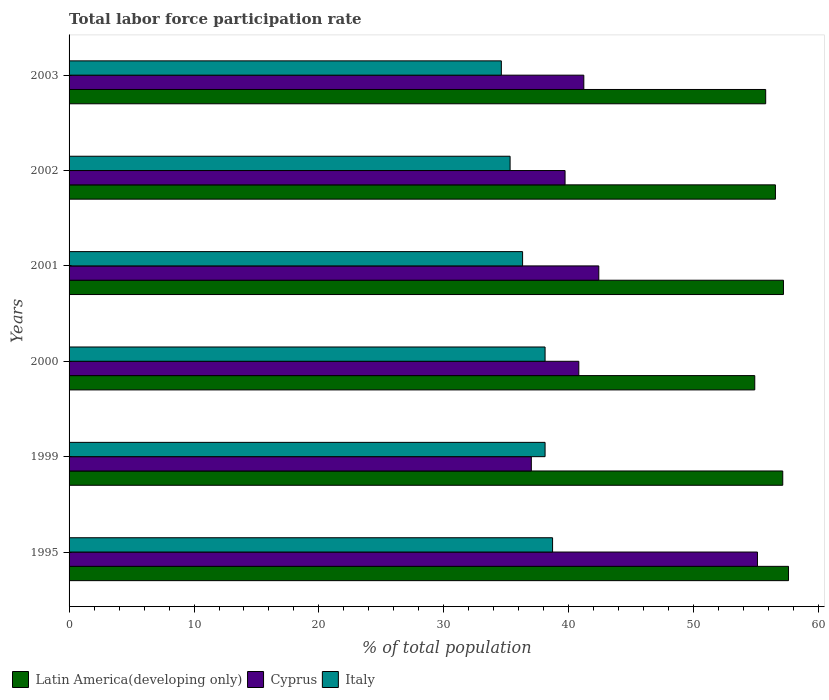How many different coloured bars are there?
Give a very brief answer. 3. Are the number of bars per tick equal to the number of legend labels?
Your answer should be compact. Yes. Are the number of bars on each tick of the Y-axis equal?
Your answer should be compact. Yes. How many bars are there on the 6th tick from the top?
Offer a very short reply. 3. How many bars are there on the 4th tick from the bottom?
Keep it short and to the point. 3. What is the label of the 3rd group of bars from the top?
Your answer should be compact. 2001. What is the total labor force participation rate in Italy in 2000?
Make the answer very short. 38.1. Across all years, what is the maximum total labor force participation rate in Cyprus?
Your answer should be compact. 55.1. Across all years, what is the minimum total labor force participation rate in Latin America(developing only)?
Give a very brief answer. 54.88. In which year was the total labor force participation rate in Cyprus maximum?
Offer a terse response. 1995. In which year was the total labor force participation rate in Latin America(developing only) minimum?
Ensure brevity in your answer.  2000. What is the total total labor force participation rate in Italy in the graph?
Make the answer very short. 221.1. What is the difference between the total labor force participation rate in Italy in 1999 and that in 2000?
Offer a very short reply. 0. What is the difference between the total labor force participation rate in Latin America(developing only) in 2000 and the total labor force participation rate in Italy in 1999?
Your answer should be compact. 16.78. What is the average total labor force participation rate in Italy per year?
Offer a terse response. 36.85. In the year 1999, what is the difference between the total labor force participation rate in Latin America(developing only) and total labor force participation rate in Cyprus?
Ensure brevity in your answer.  20.12. In how many years, is the total labor force participation rate in Cyprus greater than 54 %?
Your answer should be compact. 1. What is the ratio of the total labor force participation rate in Latin America(developing only) in 1995 to that in 2003?
Give a very brief answer. 1.03. Is the total labor force participation rate in Cyprus in 1995 less than that in 2003?
Keep it short and to the point. No. What is the difference between the highest and the second highest total labor force participation rate in Cyprus?
Provide a short and direct response. 12.7. What is the difference between the highest and the lowest total labor force participation rate in Cyprus?
Give a very brief answer. 18.1. What does the 2nd bar from the top in 1999 represents?
Make the answer very short. Cyprus. Is it the case that in every year, the sum of the total labor force participation rate in Cyprus and total labor force participation rate in Italy is greater than the total labor force participation rate in Latin America(developing only)?
Your response must be concise. Yes. How many bars are there?
Ensure brevity in your answer.  18. How many years are there in the graph?
Make the answer very short. 6. What is the difference between two consecutive major ticks on the X-axis?
Provide a short and direct response. 10. Are the values on the major ticks of X-axis written in scientific E-notation?
Give a very brief answer. No. What is the title of the graph?
Offer a very short reply. Total labor force participation rate. Does "Pacific island small states" appear as one of the legend labels in the graph?
Provide a short and direct response. No. What is the label or title of the X-axis?
Give a very brief answer. % of total population. What is the label or title of the Y-axis?
Your answer should be compact. Years. What is the % of total population in Latin America(developing only) in 1995?
Offer a terse response. 57.59. What is the % of total population of Cyprus in 1995?
Your response must be concise. 55.1. What is the % of total population of Italy in 1995?
Offer a terse response. 38.7. What is the % of total population of Latin America(developing only) in 1999?
Provide a succinct answer. 57.12. What is the % of total population in Cyprus in 1999?
Ensure brevity in your answer.  37. What is the % of total population in Italy in 1999?
Make the answer very short. 38.1. What is the % of total population in Latin America(developing only) in 2000?
Your answer should be compact. 54.88. What is the % of total population in Cyprus in 2000?
Offer a terse response. 40.8. What is the % of total population of Italy in 2000?
Give a very brief answer. 38.1. What is the % of total population of Latin America(developing only) in 2001?
Your answer should be compact. 57.18. What is the % of total population in Cyprus in 2001?
Provide a succinct answer. 42.4. What is the % of total population of Italy in 2001?
Keep it short and to the point. 36.3. What is the % of total population in Latin America(developing only) in 2002?
Give a very brief answer. 56.54. What is the % of total population of Cyprus in 2002?
Your answer should be compact. 39.7. What is the % of total population of Italy in 2002?
Give a very brief answer. 35.3. What is the % of total population of Latin America(developing only) in 2003?
Offer a terse response. 55.76. What is the % of total population in Cyprus in 2003?
Your answer should be very brief. 41.2. What is the % of total population of Italy in 2003?
Offer a very short reply. 34.6. Across all years, what is the maximum % of total population in Latin America(developing only)?
Your answer should be very brief. 57.59. Across all years, what is the maximum % of total population in Cyprus?
Give a very brief answer. 55.1. Across all years, what is the maximum % of total population of Italy?
Ensure brevity in your answer.  38.7. Across all years, what is the minimum % of total population in Latin America(developing only)?
Make the answer very short. 54.88. Across all years, what is the minimum % of total population of Italy?
Keep it short and to the point. 34.6. What is the total % of total population in Latin America(developing only) in the graph?
Provide a short and direct response. 339.07. What is the total % of total population of Cyprus in the graph?
Provide a short and direct response. 256.2. What is the total % of total population in Italy in the graph?
Provide a short and direct response. 221.1. What is the difference between the % of total population of Latin America(developing only) in 1995 and that in 1999?
Ensure brevity in your answer.  0.46. What is the difference between the % of total population of Cyprus in 1995 and that in 1999?
Provide a succinct answer. 18.1. What is the difference between the % of total population of Italy in 1995 and that in 1999?
Provide a succinct answer. 0.6. What is the difference between the % of total population in Latin America(developing only) in 1995 and that in 2000?
Keep it short and to the point. 2.7. What is the difference between the % of total population of Latin America(developing only) in 1995 and that in 2001?
Give a very brief answer. 0.41. What is the difference between the % of total population of Latin America(developing only) in 1995 and that in 2002?
Give a very brief answer. 1.05. What is the difference between the % of total population of Cyprus in 1995 and that in 2002?
Keep it short and to the point. 15.4. What is the difference between the % of total population of Italy in 1995 and that in 2002?
Ensure brevity in your answer.  3.4. What is the difference between the % of total population in Latin America(developing only) in 1995 and that in 2003?
Your response must be concise. 1.83. What is the difference between the % of total population of Cyprus in 1995 and that in 2003?
Ensure brevity in your answer.  13.9. What is the difference between the % of total population in Italy in 1995 and that in 2003?
Offer a very short reply. 4.1. What is the difference between the % of total population of Latin America(developing only) in 1999 and that in 2000?
Ensure brevity in your answer.  2.24. What is the difference between the % of total population in Cyprus in 1999 and that in 2000?
Your response must be concise. -3.8. What is the difference between the % of total population of Italy in 1999 and that in 2000?
Your response must be concise. 0. What is the difference between the % of total population in Latin America(developing only) in 1999 and that in 2001?
Ensure brevity in your answer.  -0.06. What is the difference between the % of total population in Cyprus in 1999 and that in 2001?
Your answer should be very brief. -5.4. What is the difference between the % of total population of Italy in 1999 and that in 2001?
Provide a succinct answer. 1.8. What is the difference between the % of total population of Latin America(developing only) in 1999 and that in 2002?
Provide a succinct answer. 0.59. What is the difference between the % of total population in Italy in 1999 and that in 2002?
Make the answer very short. 2.8. What is the difference between the % of total population of Latin America(developing only) in 1999 and that in 2003?
Provide a short and direct response. 1.37. What is the difference between the % of total population in Cyprus in 1999 and that in 2003?
Ensure brevity in your answer.  -4.2. What is the difference between the % of total population in Latin America(developing only) in 2000 and that in 2001?
Your response must be concise. -2.3. What is the difference between the % of total population in Italy in 2000 and that in 2001?
Keep it short and to the point. 1.8. What is the difference between the % of total population in Latin America(developing only) in 2000 and that in 2002?
Offer a very short reply. -1.65. What is the difference between the % of total population of Cyprus in 2000 and that in 2002?
Ensure brevity in your answer.  1.1. What is the difference between the % of total population in Italy in 2000 and that in 2002?
Provide a short and direct response. 2.8. What is the difference between the % of total population in Latin America(developing only) in 2000 and that in 2003?
Your response must be concise. -0.87. What is the difference between the % of total population in Italy in 2000 and that in 2003?
Offer a terse response. 3.5. What is the difference between the % of total population in Latin America(developing only) in 2001 and that in 2002?
Your answer should be compact. 0.64. What is the difference between the % of total population in Latin America(developing only) in 2001 and that in 2003?
Your answer should be very brief. 1.42. What is the difference between the % of total population of Cyprus in 2001 and that in 2003?
Offer a terse response. 1.2. What is the difference between the % of total population of Italy in 2001 and that in 2003?
Your answer should be very brief. 1.7. What is the difference between the % of total population of Latin America(developing only) in 2002 and that in 2003?
Make the answer very short. 0.78. What is the difference between the % of total population in Italy in 2002 and that in 2003?
Make the answer very short. 0.7. What is the difference between the % of total population of Latin America(developing only) in 1995 and the % of total population of Cyprus in 1999?
Ensure brevity in your answer.  20.59. What is the difference between the % of total population in Latin America(developing only) in 1995 and the % of total population in Italy in 1999?
Your response must be concise. 19.49. What is the difference between the % of total population of Latin America(developing only) in 1995 and the % of total population of Cyprus in 2000?
Offer a terse response. 16.79. What is the difference between the % of total population of Latin America(developing only) in 1995 and the % of total population of Italy in 2000?
Give a very brief answer. 19.49. What is the difference between the % of total population in Cyprus in 1995 and the % of total population in Italy in 2000?
Your answer should be compact. 17. What is the difference between the % of total population of Latin America(developing only) in 1995 and the % of total population of Cyprus in 2001?
Give a very brief answer. 15.19. What is the difference between the % of total population in Latin America(developing only) in 1995 and the % of total population in Italy in 2001?
Keep it short and to the point. 21.29. What is the difference between the % of total population in Latin America(developing only) in 1995 and the % of total population in Cyprus in 2002?
Ensure brevity in your answer.  17.89. What is the difference between the % of total population in Latin America(developing only) in 1995 and the % of total population in Italy in 2002?
Your answer should be very brief. 22.29. What is the difference between the % of total population of Cyprus in 1995 and the % of total population of Italy in 2002?
Make the answer very short. 19.8. What is the difference between the % of total population in Latin America(developing only) in 1995 and the % of total population in Cyprus in 2003?
Offer a very short reply. 16.39. What is the difference between the % of total population in Latin America(developing only) in 1995 and the % of total population in Italy in 2003?
Offer a terse response. 22.99. What is the difference between the % of total population of Latin America(developing only) in 1999 and the % of total population of Cyprus in 2000?
Your answer should be very brief. 16.32. What is the difference between the % of total population in Latin America(developing only) in 1999 and the % of total population in Italy in 2000?
Keep it short and to the point. 19.02. What is the difference between the % of total population of Cyprus in 1999 and the % of total population of Italy in 2000?
Keep it short and to the point. -1.1. What is the difference between the % of total population in Latin America(developing only) in 1999 and the % of total population in Cyprus in 2001?
Offer a terse response. 14.72. What is the difference between the % of total population in Latin America(developing only) in 1999 and the % of total population in Italy in 2001?
Your answer should be compact. 20.82. What is the difference between the % of total population of Cyprus in 1999 and the % of total population of Italy in 2001?
Your answer should be very brief. 0.7. What is the difference between the % of total population in Latin America(developing only) in 1999 and the % of total population in Cyprus in 2002?
Your response must be concise. 17.42. What is the difference between the % of total population in Latin America(developing only) in 1999 and the % of total population in Italy in 2002?
Make the answer very short. 21.82. What is the difference between the % of total population of Latin America(developing only) in 1999 and the % of total population of Cyprus in 2003?
Keep it short and to the point. 15.92. What is the difference between the % of total population of Latin America(developing only) in 1999 and the % of total population of Italy in 2003?
Ensure brevity in your answer.  22.52. What is the difference between the % of total population of Latin America(developing only) in 2000 and the % of total population of Cyprus in 2001?
Keep it short and to the point. 12.48. What is the difference between the % of total population of Latin America(developing only) in 2000 and the % of total population of Italy in 2001?
Make the answer very short. 18.58. What is the difference between the % of total population in Cyprus in 2000 and the % of total population in Italy in 2001?
Provide a short and direct response. 4.5. What is the difference between the % of total population of Latin America(developing only) in 2000 and the % of total population of Cyprus in 2002?
Your response must be concise. 15.18. What is the difference between the % of total population in Latin America(developing only) in 2000 and the % of total population in Italy in 2002?
Give a very brief answer. 19.58. What is the difference between the % of total population in Latin America(developing only) in 2000 and the % of total population in Cyprus in 2003?
Keep it short and to the point. 13.68. What is the difference between the % of total population in Latin America(developing only) in 2000 and the % of total population in Italy in 2003?
Keep it short and to the point. 20.28. What is the difference between the % of total population in Latin America(developing only) in 2001 and the % of total population in Cyprus in 2002?
Make the answer very short. 17.48. What is the difference between the % of total population of Latin America(developing only) in 2001 and the % of total population of Italy in 2002?
Keep it short and to the point. 21.88. What is the difference between the % of total population in Cyprus in 2001 and the % of total population in Italy in 2002?
Offer a very short reply. 7.1. What is the difference between the % of total population in Latin America(developing only) in 2001 and the % of total population in Cyprus in 2003?
Keep it short and to the point. 15.98. What is the difference between the % of total population in Latin America(developing only) in 2001 and the % of total population in Italy in 2003?
Your answer should be compact. 22.58. What is the difference between the % of total population in Latin America(developing only) in 2002 and the % of total population in Cyprus in 2003?
Your answer should be very brief. 15.34. What is the difference between the % of total population in Latin America(developing only) in 2002 and the % of total population in Italy in 2003?
Offer a terse response. 21.94. What is the average % of total population in Latin America(developing only) per year?
Provide a succinct answer. 56.51. What is the average % of total population in Cyprus per year?
Your answer should be very brief. 42.7. What is the average % of total population in Italy per year?
Keep it short and to the point. 36.85. In the year 1995, what is the difference between the % of total population in Latin America(developing only) and % of total population in Cyprus?
Your answer should be very brief. 2.49. In the year 1995, what is the difference between the % of total population of Latin America(developing only) and % of total population of Italy?
Ensure brevity in your answer.  18.89. In the year 1999, what is the difference between the % of total population in Latin America(developing only) and % of total population in Cyprus?
Provide a short and direct response. 20.12. In the year 1999, what is the difference between the % of total population of Latin America(developing only) and % of total population of Italy?
Your answer should be very brief. 19.02. In the year 1999, what is the difference between the % of total population in Cyprus and % of total population in Italy?
Keep it short and to the point. -1.1. In the year 2000, what is the difference between the % of total population of Latin America(developing only) and % of total population of Cyprus?
Make the answer very short. 14.08. In the year 2000, what is the difference between the % of total population in Latin America(developing only) and % of total population in Italy?
Give a very brief answer. 16.78. In the year 2001, what is the difference between the % of total population of Latin America(developing only) and % of total population of Cyprus?
Give a very brief answer. 14.78. In the year 2001, what is the difference between the % of total population in Latin America(developing only) and % of total population in Italy?
Give a very brief answer. 20.88. In the year 2002, what is the difference between the % of total population in Latin America(developing only) and % of total population in Cyprus?
Your answer should be compact. 16.84. In the year 2002, what is the difference between the % of total population in Latin America(developing only) and % of total population in Italy?
Offer a very short reply. 21.24. In the year 2002, what is the difference between the % of total population in Cyprus and % of total population in Italy?
Provide a succinct answer. 4.4. In the year 2003, what is the difference between the % of total population in Latin America(developing only) and % of total population in Cyprus?
Provide a succinct answer. 14.56. In the year 2003, what is the difference between the % of total population in Latin America(developing only) and % of total population in Italy?
Your answer should be compact. 21.16. In the year 2003, what is the difference between the % of total population of Cyprus and % of total population of Italy?
Ensure brevity in your answer.  6.6. What is the ratio of the % of total population of Cyprus in 1995 to that in 1999?
Offer a very short reply. 1.49. What is the ratio of the % of total population of Italy in 1995 to that in 1999?
Keep it short and to the point. 1.02. What is the ratio of the % of total population of Latin America(developing only) in 1995 to that in 2000?
Keep it short and to the point. 1.05. What is the ratio of the % of total population in Cyprus in 1995 to that in 2000?
Keep it short and to the point. 1.35. What is the ratio of the % of total population in Italy in 1995 to that in 2000?
Keep it short and to the point. 1.02. What is the ratio of the % of total population of Latin America(developing only) in 1995 to that in 2001?
Provide a short and direct response. 1.01. What is the ratio of the % of total population in Cyprus in 1995 to that in 2001?
Provide a short and direct response. 1.3. What is the ratio of the % of total population of Italy in 1995 to that in 2001?
Ensure brevity in your answer.  1.07. What is the ratio of the % of total population in Latin America(developing only) in 1995 to that in 2002?
Offer a terse response. 1.02. What is the ratio of the % of total population of Cyprus in 1995 to that in 2002?
Ensure brevity in your answer.  1.39. What is the ratio of the % of total population in Italy in 1995 to that in 2002?
Provide a succinct answer. 1.1. What is the ratio of the % of total population of Latin America(developing only) in 1995 to that in 2003?
Keep it short and to the point. 1.03. What is the ratio of the % of total population in Cyprus in 1995 to that in 2003?
Ensure brevity in your answer.  1.34. What is the ratio of the % of total population of Italy in 1995 to that in 2003?
Your response must be concise. 1.12. What is the ratio of the % of total population of Latin America(developing only) in 1999 to that in 2000?
Provide a succinct answer. 1.04. What is the ratio of the % of total population in Cyprus in 1999 to that in 2000?
Provide a short and direct response. 0.91. What is the ratio of the % of total population of Italy in 1999 to that in 2000?
Your answer should be very brief. 1. What is the ratio of the % of total population of Latin America(developing only) in 1999 to that in 2001?
Keep it short and to the point. 1. What is the ratio of the % of total population of Cyprus in 1999 to that in 2001?
Keep it short and to the point. 0.87. What is the ratio of the % of total population of Italy in 1999 to that in 2001?
Offer a terse response. 1.05. What is the ratio of the % of total population in Latin America(developing only) in 1999 to that in 2002?
Give a very brief answer. 1.01. What is the ratio of the % of total population in Cyprus in 1999 to that in 2002?
Make the answer very short. 0.93. What is the ratio of the % of total population in Italy in 1999 to that in 2002?
Your response must be concise. 1.08. What is the ratio of the % of total population in Latin America(developing only) in 1999 to that in 2003?
Give a very brief answer. 1.02. What is the ratio of the % of total population of Cyprus in 1999 to that in 2003?
Provide a succinct answer. 0.9. What is the ratio of the % of total population in Italy in 1999 to that in 2003?
Provide a succinct answer. 1.1. What is the ratio of the % of total population in Latin America(developing only) in 2000 to that in 2001?
Offer a very short reply. 0.96. What is the ratio of the % of total population of Cyprus in 2000 to that in 2001?
Offer a very short reply. 0.96. What is the ratio of the % of total population of Italy in 2000 to that in 2001?
Your answer should be very brief. 1.05. What is the ratio of the % of total population in Latin America(developing only) in 2000 to that in 2002?
Keep it short and to the point. 0.97. What is the ratio of the % of total population of Cyprus in 2000 to that in 2002?
Provide a short and direct response. 1.03. What is the ratio of the % of total population in Italy in 2000 to that in 2002?
Ensure brevity in your answer.  1.08. What is the ratio of the % of total population of Latin America(developing only) in 2000 to that in 2003?
Give a very brief answer. 0.98. What is the ratio of the % of total population of Cyprus in 2000 to that in 2003?
Make the answer very short. 0.99. What is the ratio of the % of total population in Italy in 2000 to that in 2003?
Provide a succinct answer. 1.1. What is the ratio of the % of total population of Latin America(developing only) in 2001 to that in 2002?
Provide a succinct answer. 1.01. What is the ratio of the % of total population of Cyprus in 2001 to that in 2002?
Keep it short and to the point. 1.07. What is the ratio of the % of total population in Italy in 2001 to that in 2002?
Offer a very short reply. 1.03. What is the ratio of the % of total population of Latin America(developing only) in 2001 to that in 2003?
Your response must be concise. 1.03. What is the ratio of the % of total population in Cyprus in 2001 to that in 2003?
Your response must be concise. 1.03. What is the ratio of the % of total population of Italy in 2001 to that in 2003?
Give a very brief answer. 1.05. What is the ratio of the % of total population in Latin America(developing only) in 2002 to that in 2003?
Provide a short and direct response. 1.01. What is the ratio of the % of total population in Cyprus in 2002 to that in 2003?
Provide a succinct answer. 0.96. What is the ratio of the % of total population of Italy in 2002 to that in 2003?
Make the answer very short. 1.02. What is the difference between the highest and the second highest % of total population in Latin America(developing only)?
Give a very brief answer. 0.41. What is the difference between the highest and the second highest % of total population in Italy?
Provide a succinct answer. 0.6. What is the difference between the highest and the lowest % of total population in Latin America(developing only)?
Keep it short and to the point. 2.7. What is the difference between the highest and the lowest % of total population of Cyprus?
Ensure brevity in your answer.  18.1. 